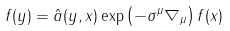<formula> <loc_0><loc_0><loc_500><loc_500>f ( y ) = { \hat { a } } ( y , x ) \exp \left ( - \sigma ^ { \mu } \nabla _ { \mu } \right ) f ( x )</formula> 